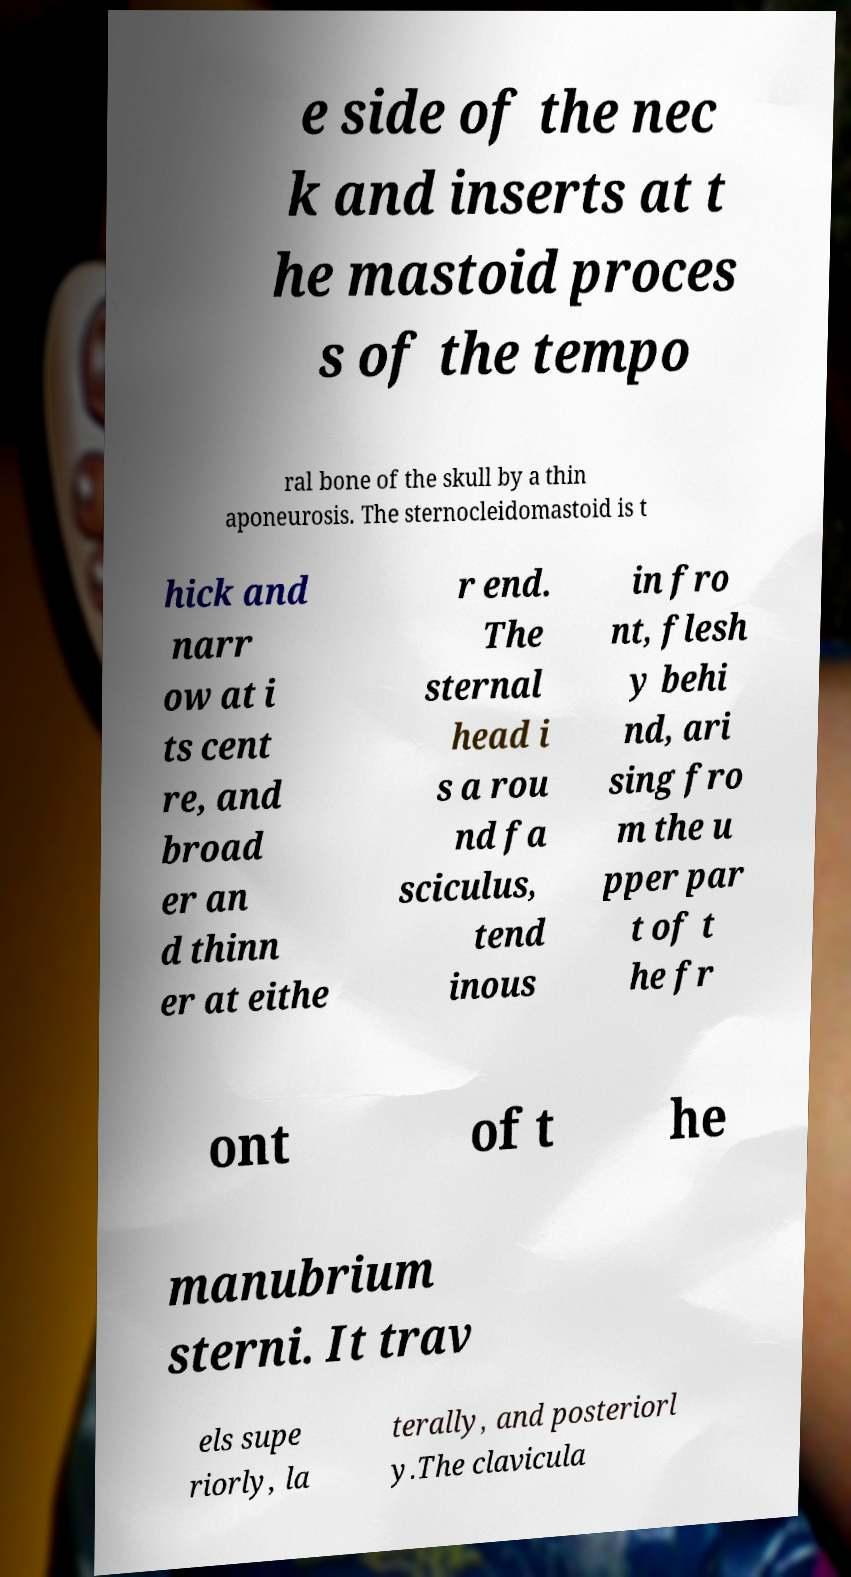Can you accurately transcribe the text from the provided image for me? e side of the nec k and inserts at t he mastoid proces s of the tempo ral bone of the skull by a thin aponeurosis. The sternocleidomastoid is t hick and narr ow at i ts cent re, and broad er an d thinn er at eithe r end. The sternal head i s a rou nd fa sciculus, tend inous in fro nt, flesh y behi nd, ari sing fro m the u pper par t of t he fr ont of t he manubrium sterni. It trav els supe riorly, la terally, and posteriorl y.The clavicula 